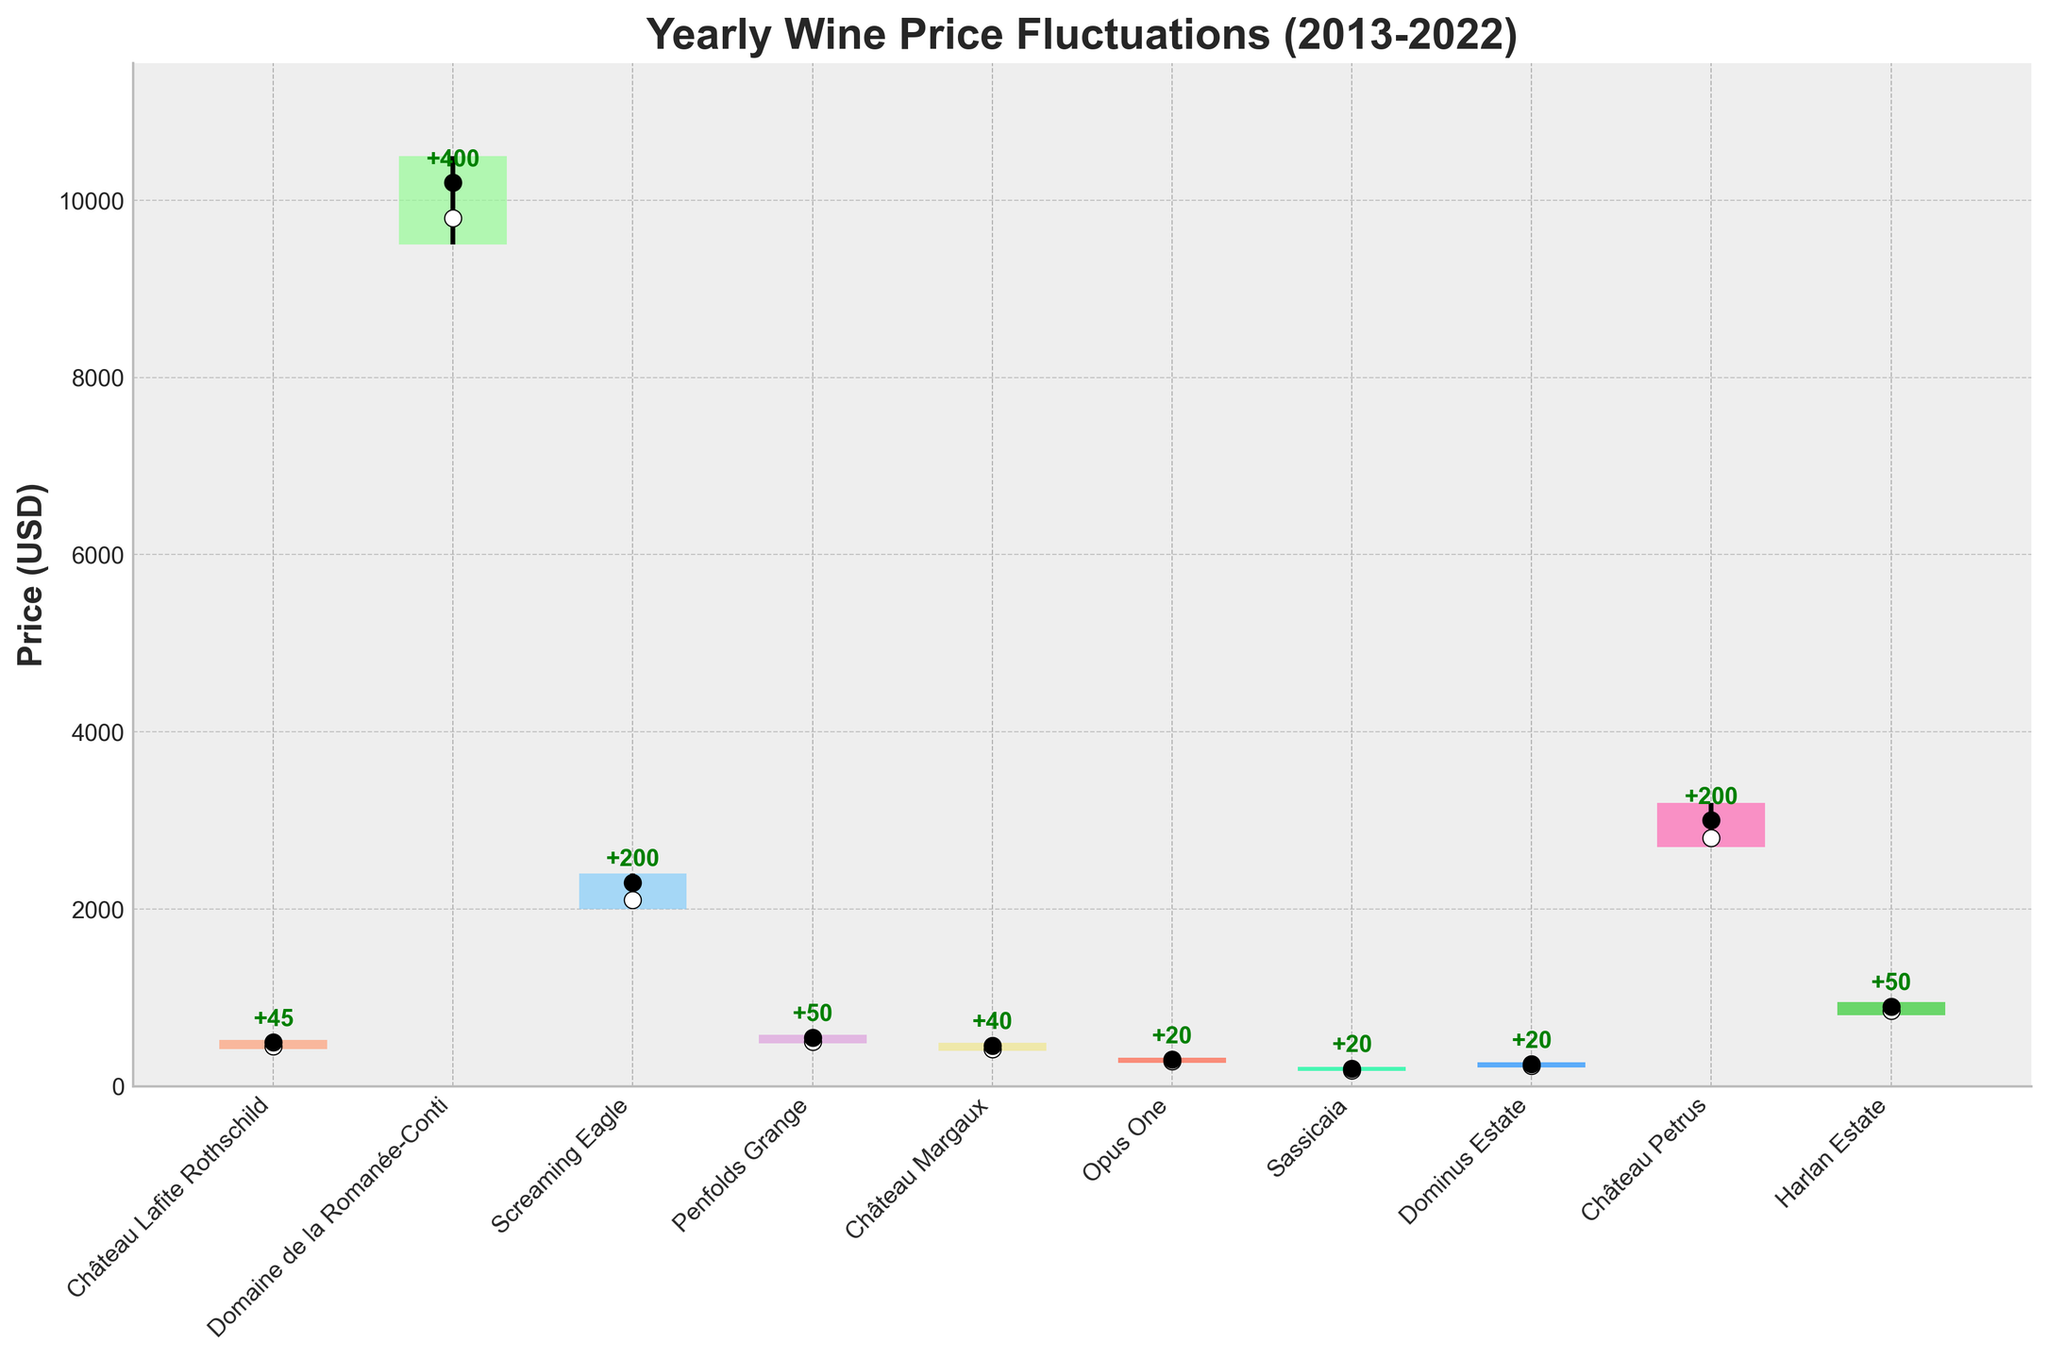what does the title of the chart say? The title of the chart is usually at the top and represents the main subject. In this case, we look there to find the title.
Answer: Yearly Wine Price Fluctuations (2013-2022) How many vineyards are represented in the chart? By counting the number of unique names on the x-axis, we determine the number of vineyards.
Answer: 10 Which vineyard has the highest closing price? By comparing the closing prices of all vineyards, which are represented by black dots, we can identify the vineyard with the highest value. Château Petrus has the highest closing price, indicated by the highest black dot position.
Answer: Château Petrus For Château Lafite Rothschild, did the price increase or decrease over the year 2013? By comparing the open price and close price for Château Lafite Rothschild, we establish if the closing price is higher or lower than the opening price. If the closing price (495) is higher than the opening price (450), the price increased.
Answer: increased What is the median closing price among all vineyards? First, list all closing prices (495, 10200, 2300, 550, 460, 300, 200, 250, 3000, 900). Sort these values (195, 250, 300, 460, 495, 550, 900, 2300, 3000, 10200) and find the middle value(s). For 10 vineyards, the median is the average of the 5th and 6th values: (495 + 550) / 2 = 522.5.
Answer: 522.5 Was the price range (high - low) for Domaine de la Romanée-Conti greater than for Harlan Estate? Calculate the price range for both vineyards: Domaine de la Romanée-Conti (10500 - 9500 = 1000), Harlan Estate (950 - 800 = 150). Domaine de la Romanée-Conti has a greater price range.
Answer: Yes Which vineyard has the smallest fluctuation range (difference between high and low) in their wine prices? Calculate the difference between high and low prices for each vineyard and identify the smallest value. Sassicaia has the smallest fluctuation (220 - 170 = 50).
Answer: Sassicaia What was the highest price (high) for Château Margaux and how does it compare to the lowest price (low) for Screaming Eagle? Look at both the highest price for Château Margaux (490) and the lowest price for Screaming Eagle (200) and compare them. 490 is greater than 200, so Château Margaux's highest price is higher.
Answer: higher Which vineyard experienced the largest increase in wine price over a year? By examining the annotations which indicate the difference between open and close prices, Domaine de la Romanée-Conti shows the largest increase of +400.
Answer: Domaine de la Romanée-Conti Was there any vineyard whose closing price was less than its opening price? Compare opening prices and closing prices for all vineyards from the chart. Yes, Opus One has a closing price (300) less than its opening price (280).
Answer: Yes 